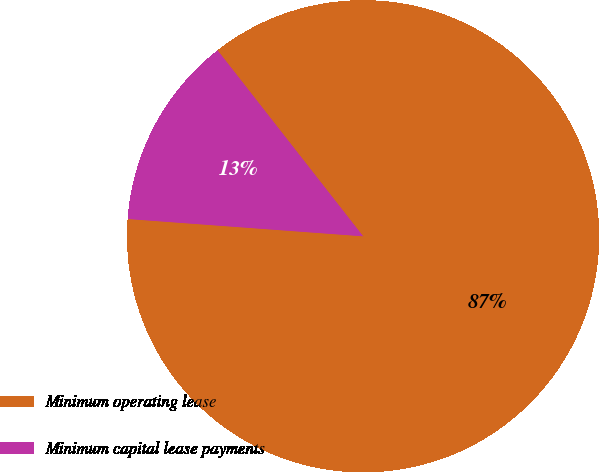<chart> <loc_0><loc_0><loc_500><loc_500><pie_chart><fcel>Minimum operating lease<fcel>Minimum capital lease payments<nl><fcel>86.74%<fcel>13.26%<nl></chart> 